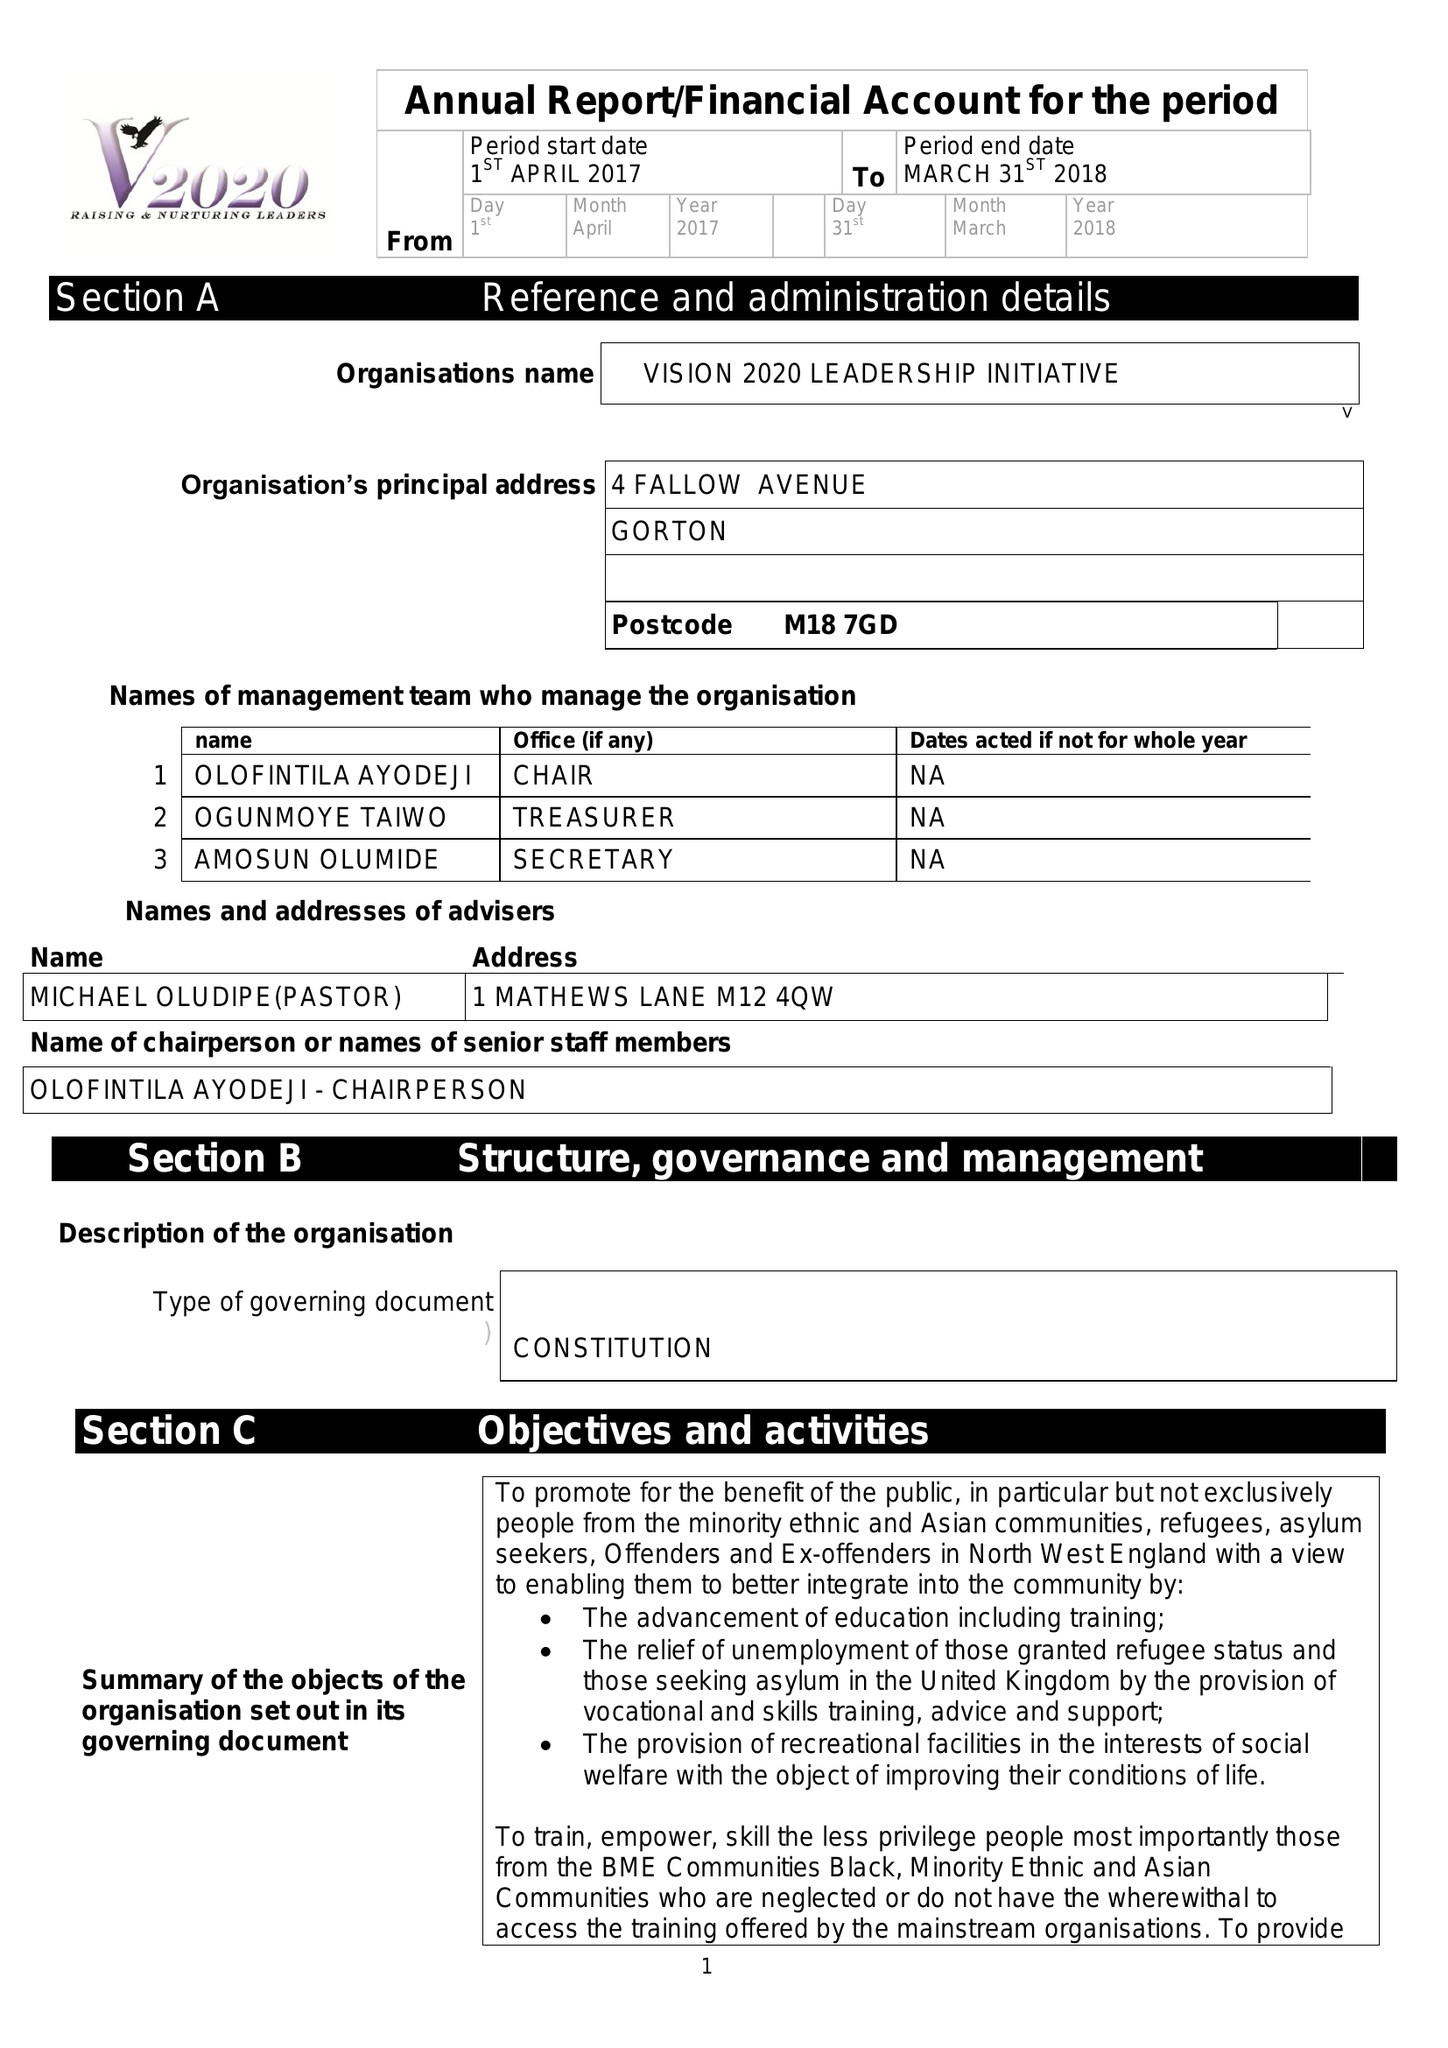What is the value for the charity_number?
Answer the question using a single word or phrase. 1142264 